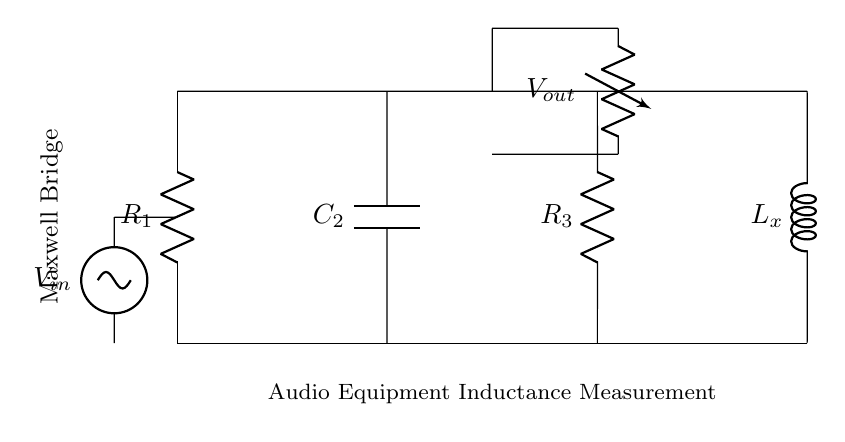What are the components in the Maxwell bridge? The components shown in the diagram include one resistor labeled R1, one capacitor labeled C2, another resistor labeled R3, and one inductor labeled Lx.
Answer: R1, C2, R3, Lx What is the input voltage source labeled in the circuit? The input voltage source is labeled as Vin, indicating it is connected to the circuit to provide power.
Answer: Vin What is the output voltage measured across? The output voltage, denoted as Vout, is measured across two points within the bridge, specifically between the connections at points 7 and 5.
Answer: Vout What is the total resistance connected in series? The total resistance in series includes R1 and R3, which are both placed vertically in the diagram.
Answer: R1 + R3 How does the Maxwell bridge balance condition help in inductance measurement? The Maxwell bridge achieves balance by adjusting R2 (the capacitor) to match the impedance of the inductor (Lx), which allows for accurate measurement of inductance when the bridge is balanced.
Answer: It allows accurate inductance measurement What does the node labeled with R3 indicate about the circuit configuration? The node labeled R3 indicates that it is part of the bridge configuration, as it connects the top part of the bridge to the output measuring point, contributing to the overall impedance in the circuit.
Answer: It is part of the bridge configuration What does the horizontal line in the circuit signify? The horizontal line at the bottom indicates the ground or common reference point for the circuit, along which components are connected.
Answer: Ground 